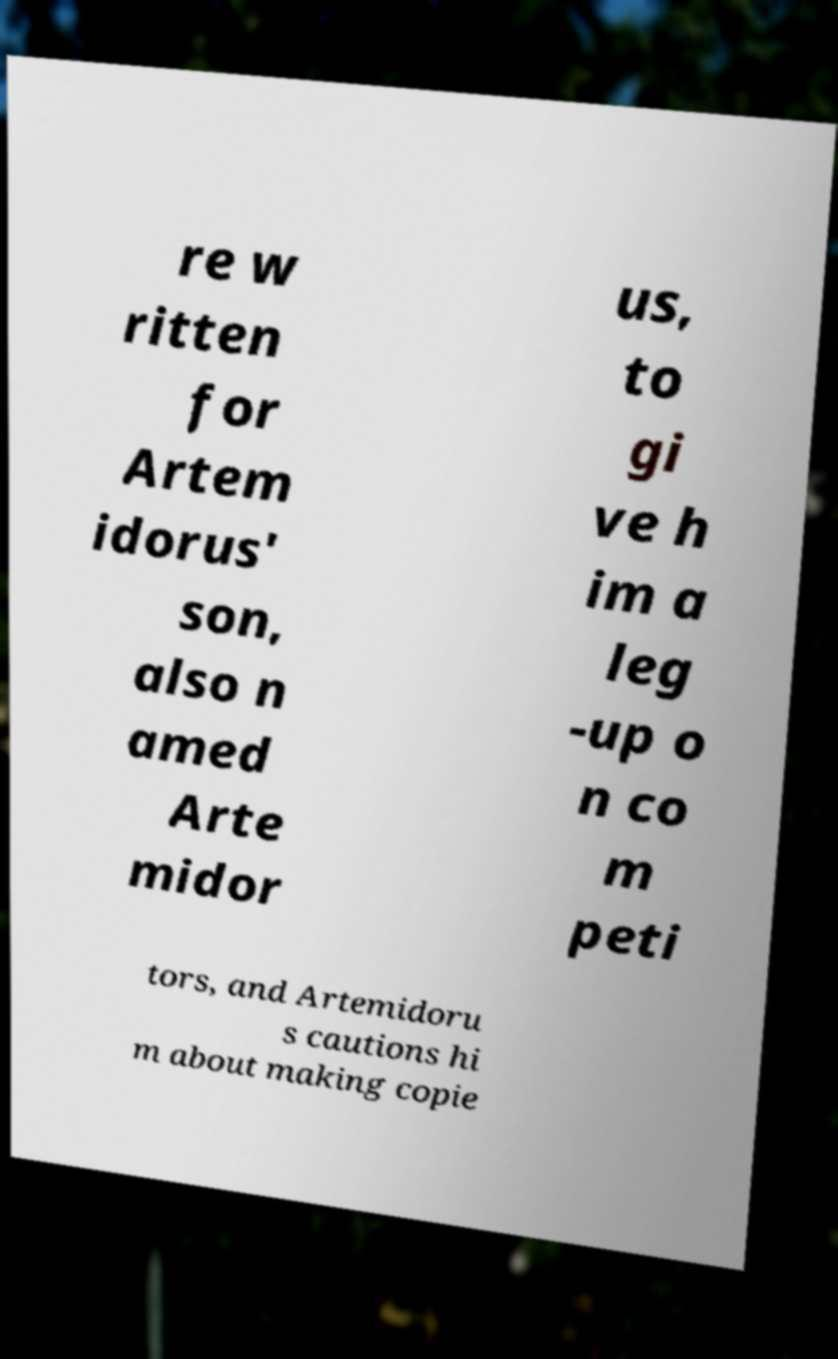Can you read and provide the text displayed in the image?This photo seems to have some interesting text. Can you extract and type it out for me? re w ritten for Artem idorus' son, also n amed Arte midor us, to gi ve h im a leg -up o n co m peti tors, and Artemidoru s cautions hi m about making copie 